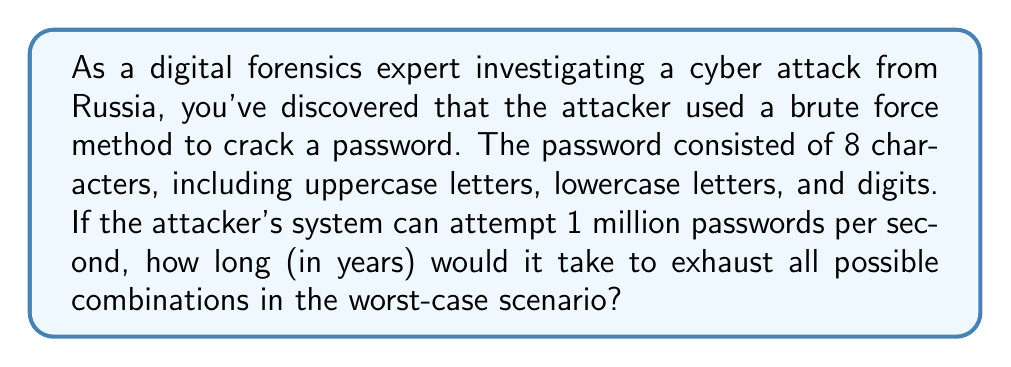Teach me how to tackle this problem. Let's approach this step-by-step:

1. First, we need to calculate the total number of possible combinations:
   - Uppercase letters: 26
   - Lowercase letters: 26
   - Digits: 10
   Total character set: 26 + 26 + 10 = 62

2. For an 8-character password, the number of possible combinations is:
   $$ 62^8 = 218,340,105,584,896 $$

3. Now, let's calculate how many attempts the system can make:
   - Per second: 1,000,000
   - Per minute: 60,000,000
   - Per hour: 3,600,000,000
   - Per day: 86,400,000,000
   - Per year: 31,536,000,000,000

4. To find the number of years, we divide the total combinations by attempts per year:
   $$ \text{Years} = \frac{218,340,105,584,896}{31,536,000,000,000} \approx 6.92 $$

5. Converting to years, months, and days:
   - 6 years
   - 0.92 years * 12 = 11.04 months
   - 0.04 months * 30 ≈ 1.2 days
Answer: 6 years, 11 months, and 1 day 